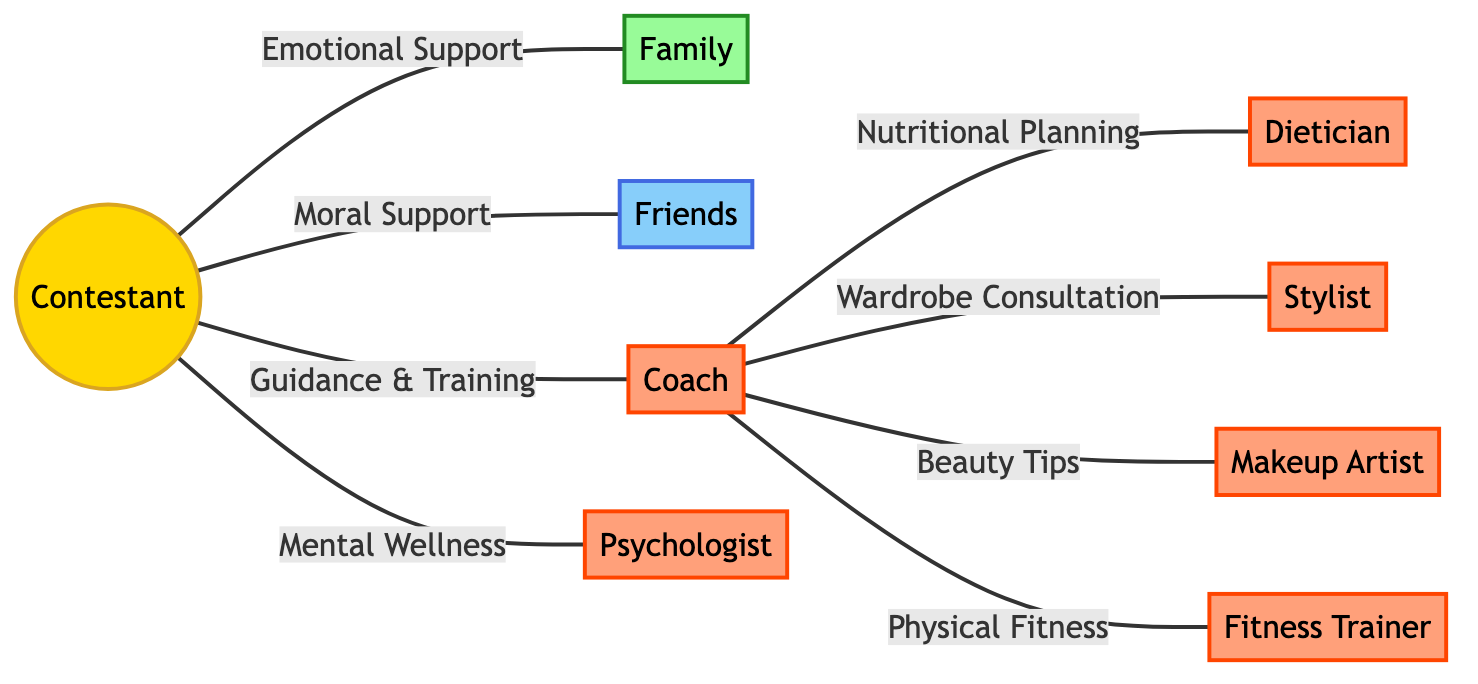What is the total number of nodes in the diagram? The diagram clearly lists nine different nodes: Contestant, Family, Friends, Coach, Dietician, Stylist, Makeup Artist, Fitness Trainer, and Psychologist. Counting these gives a total of nine nodes.
Answer: 9 Who provides Emotional Support to the Contestant? In the diagram, the edge labeled "Emotional Support" clearly shows that the Family is connected to the Contestant. This indicates that Family provides Emotional Support.
Answer: Family What is the function of the connection between Coach and Dietician? The edge connecting Coach to Dietician is labeled "Nutritional Planning," indicating that Dietician's function is to support the Contestant in terms of nutrition via the Coach.
Answer: Nutritional Planning Which professional is connected directly to the Contestant for Mental Wellness? The edge labeled "Mental Wellness" shows that the Psychologist is connected directly to the Contestant, indicating that the Psychologist provides support in this area.
Answer: Psychologist How many professional support roles are there in this diagram? The diagram identifies five professional support roles: Coach, Dietician, Stylist, Makeup Artist, and Fitness Trainer. Therefore, counting these gives a total of five professional support roles.
Answer: 5 What type of support do Friends provide the Contestant? The edge labeled "Moral Support" illustrates that Friends specifically provide this type of support to the Contestant, clarifying their role in the network.
Answer: Moral Support Who does the Coach provide Beauty Tips to? According to the diagram, the edge labeled "Beauty Tips" indicates that the Coach connects to the Makeup Artist. This implies that the Coach utilizes the Makeup Artist for providing beauty tips.
Answer: Makeup Artist Which two nodes are interconnected through Guidance & Training? The edge labeled "Guidance & Training" directly connects the Contestant with the Coach. This shows that the Coach is responsible for providing guidance and training to the Contestant.
Answer: Coach and Contestant What is a key function of the Fitness Trainer related to the Contestant? The edge labeled "Physical Fitness" shows that the Fitness Trainer is connected to the Coach, which suggests that the Trainer helps maintain the physical fitness aspect for the Contestant through the Coach's guidance.
Answer: Physical Fitness 